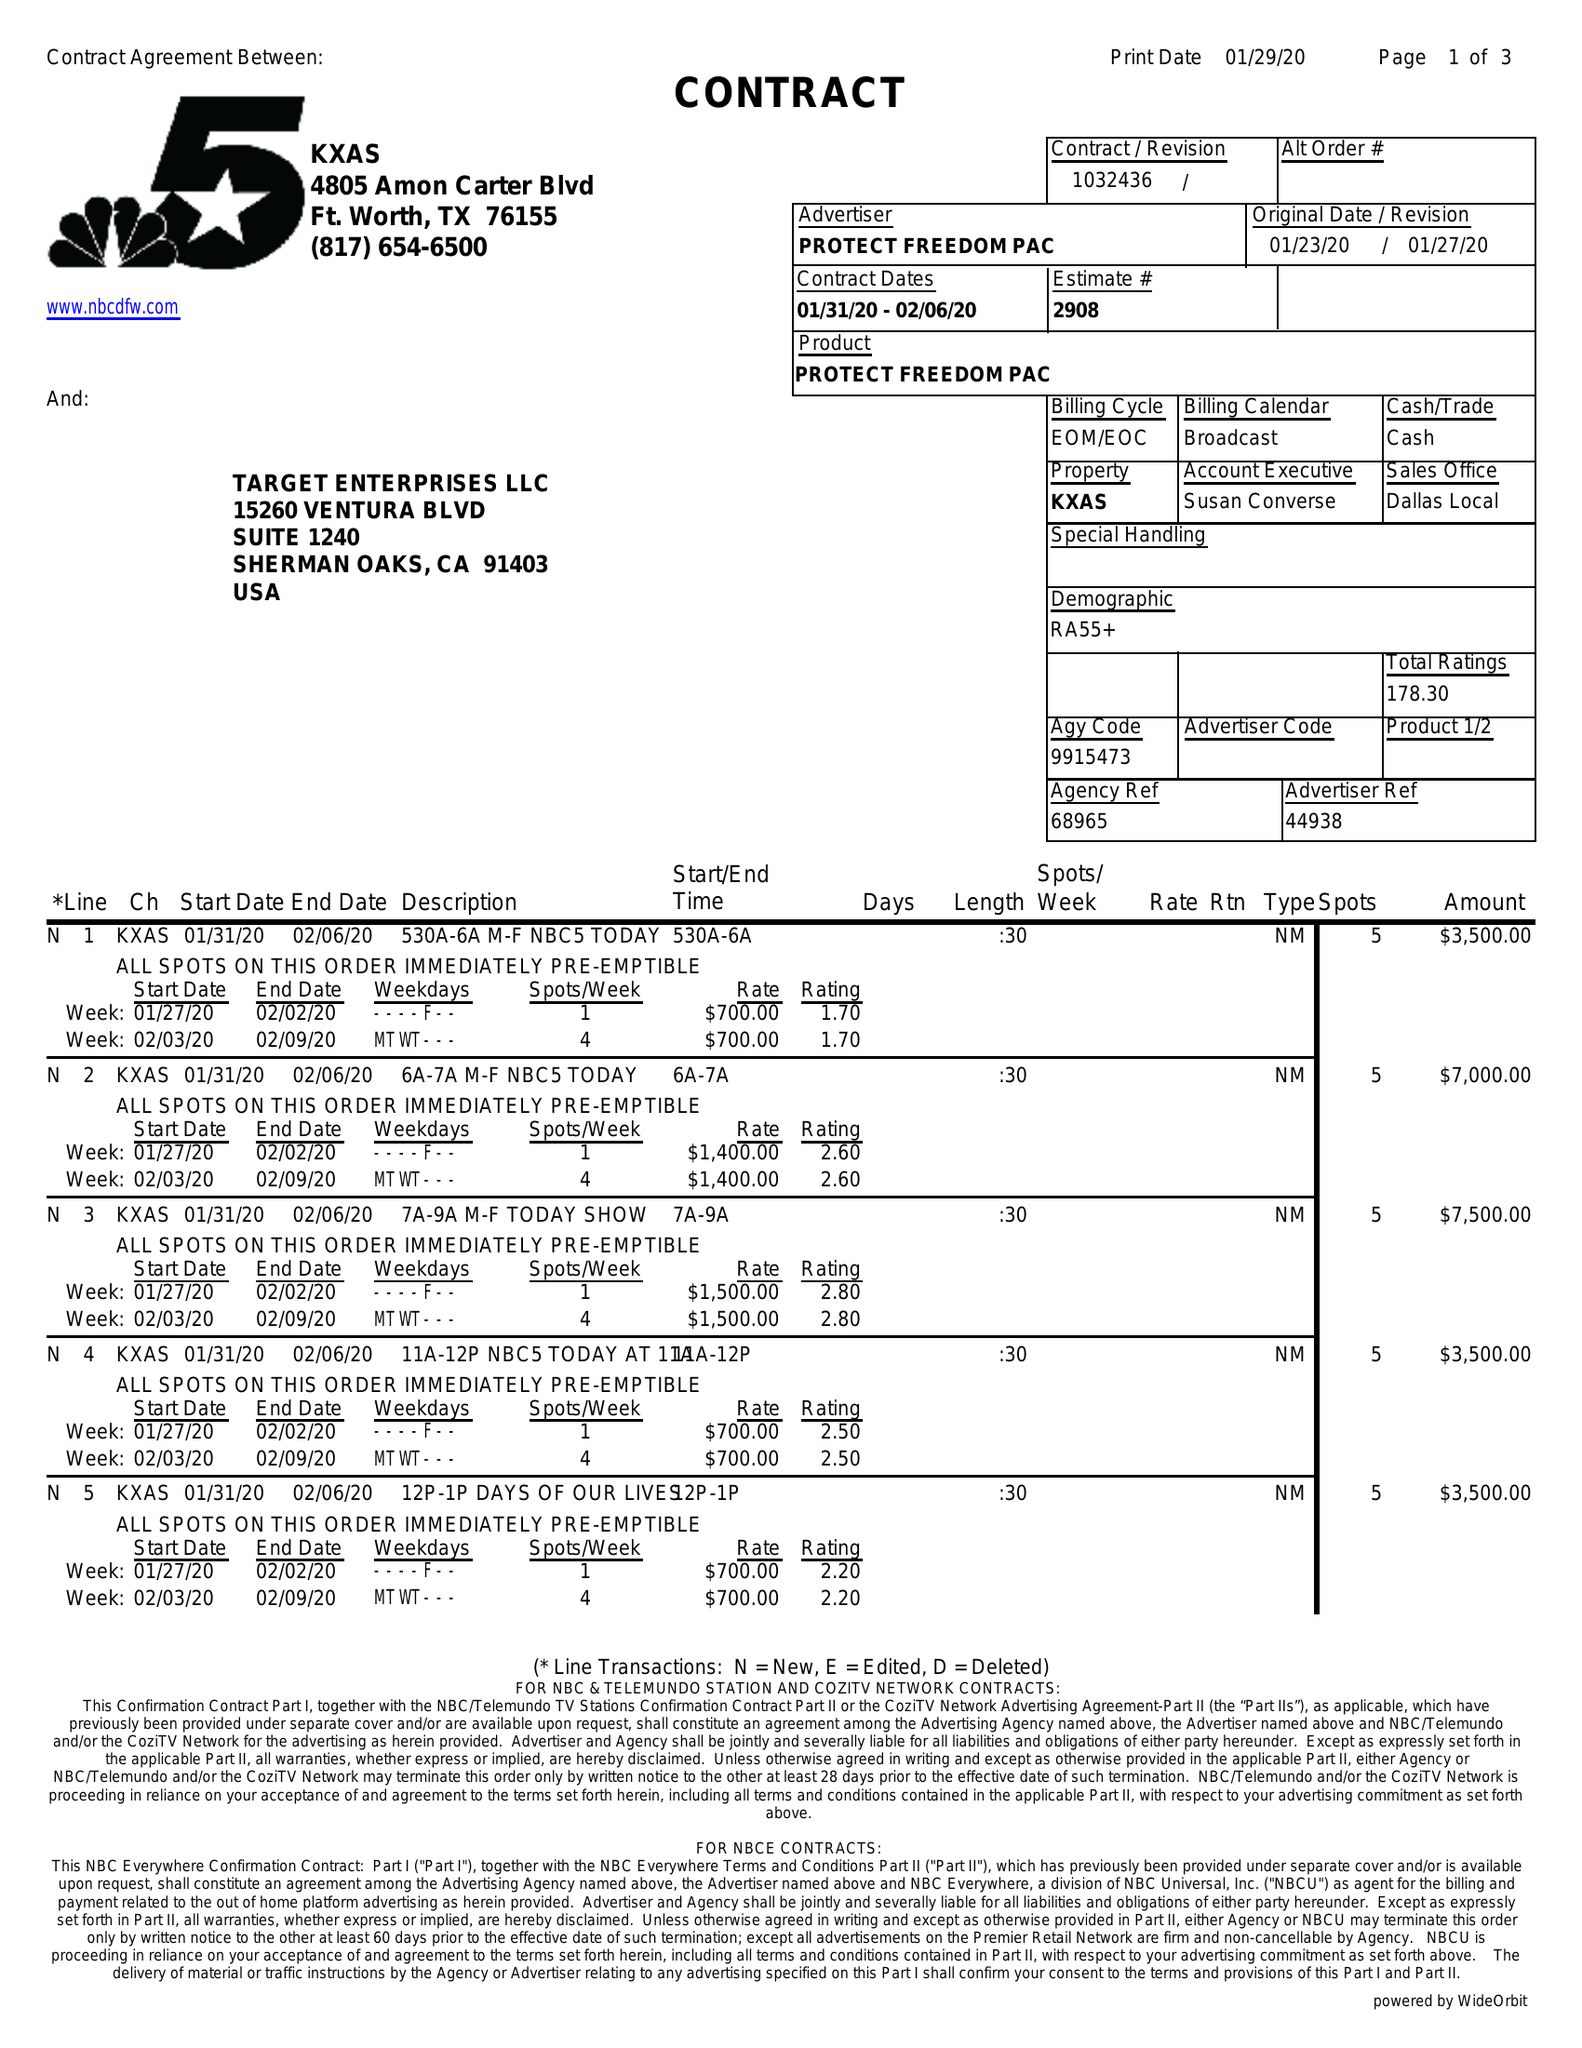What is the value for the flight_to?
Answer the question using a single word or phrase. 02/06/20 